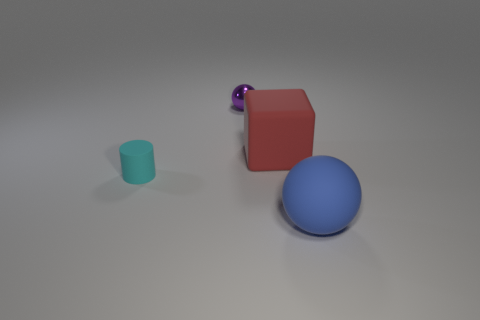Add 2 small cyan matte cylinders. How many objects exist? 6 Subtract 1 balls. How many balls are left? 1 Subtract all gray cylinders. Subtract all gray cubes. How many cylinders are left? 1 Subtract all large matte balls. Subtract all balls. How many objects are left? 1 Add 3 matte spheres. How many matte spheres are left? 4 Add 3 small purple things. How many small purple things exist? 4 Subtract 0 red balls. How many objects are left? 4 Subtract all cubes. How many objects are left? 3 